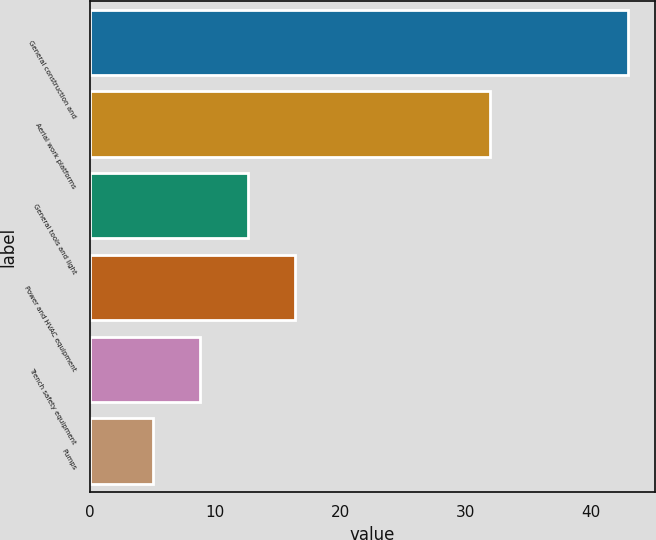<chart> <loc_0><loc_0><loc_500><loc_500><bar_chart><fcel>General construction and<fcel>Aerial work platforms<fcel>General tools and light<fcel>Power and HVAC equipment<fcel>Trench safety equipment<fcel>Pumps<nl><fcel>43<fcel>32<fcel>12.6<fcel>16.4<fcel>8.8<fcel>5<nl></chart> 